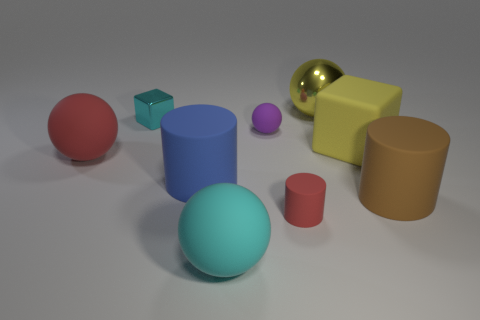Subtract all purple balls. How many balls are left? 3 Add 1 tiny cyan metal things. How many objects exist? 10 Subtract all cylinders. How many objects are left? 6 Subtract all red spheres. How many spheres are left? 3 Subtract 0 green spheres. How many objects are left? 9 Subtract 3 spheres. How many spheres are left? 1 Subtract all blue cylinders. Subtract all blue balls. How many cylinders are left? 2 Subtract all brown cylinders. How many brown cubes are left? 0 Subtract all small rubber objects. Subtract all yellow cubes. How many objects are left? 6 Add 1 tiny metal blocks. How many tiny metal blocks are left? 2 